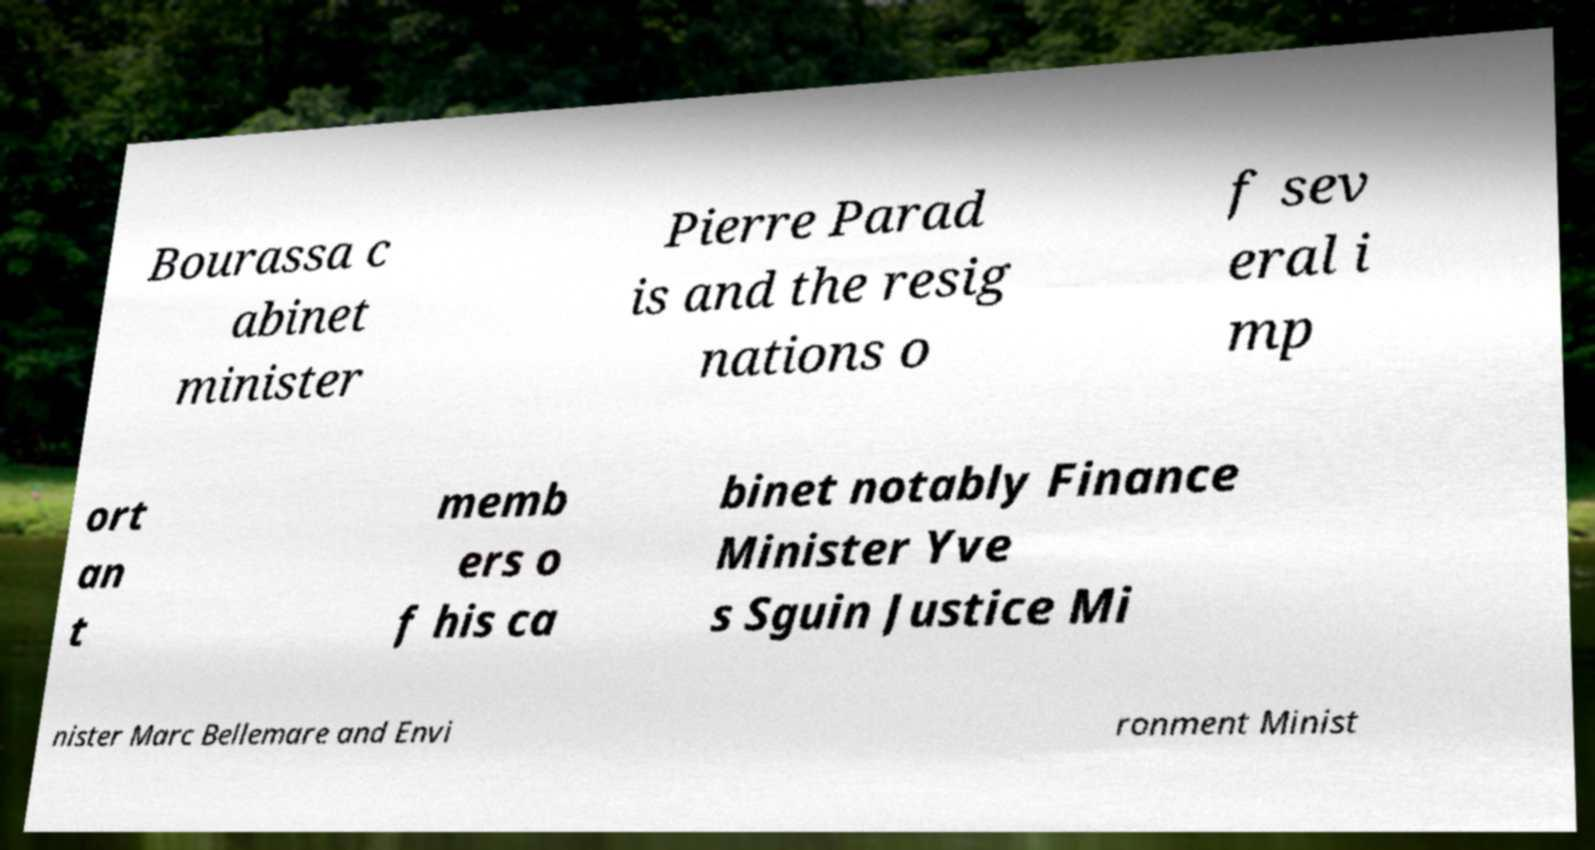Can you read and provide the text displayed in the image?This photo seems to have some interesting text. Can you extract and type it out for me? Bourassa c abinet minister Pierre Parad is and the resig nations o f sev eral i mp ort an t memb ers o f his ca binet notably Finance Minister Yve s Sguin Justice Mi nister Marc Bellemare and Envi ronment Minist 